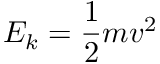Convert formula to latex. <formula><loc_0><loc_0><loc_500><loc_500>E _ { k } = { \frac { 1 } { 2 } } m v ^ { 2 }</formula> 